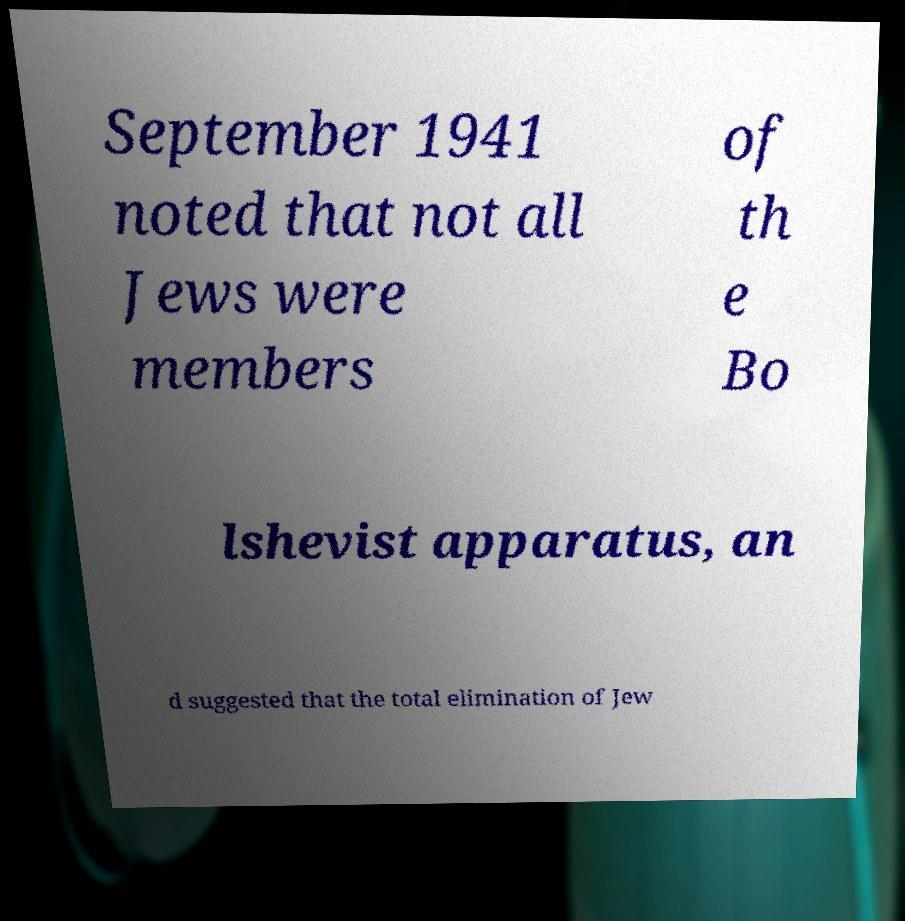Could you assist in decoding the text presented in this image and type it out clearly? September 1941 noted that not all Jews were members of th e Bo lshevist apparatus, an d suggested that the total elimination of Jew 